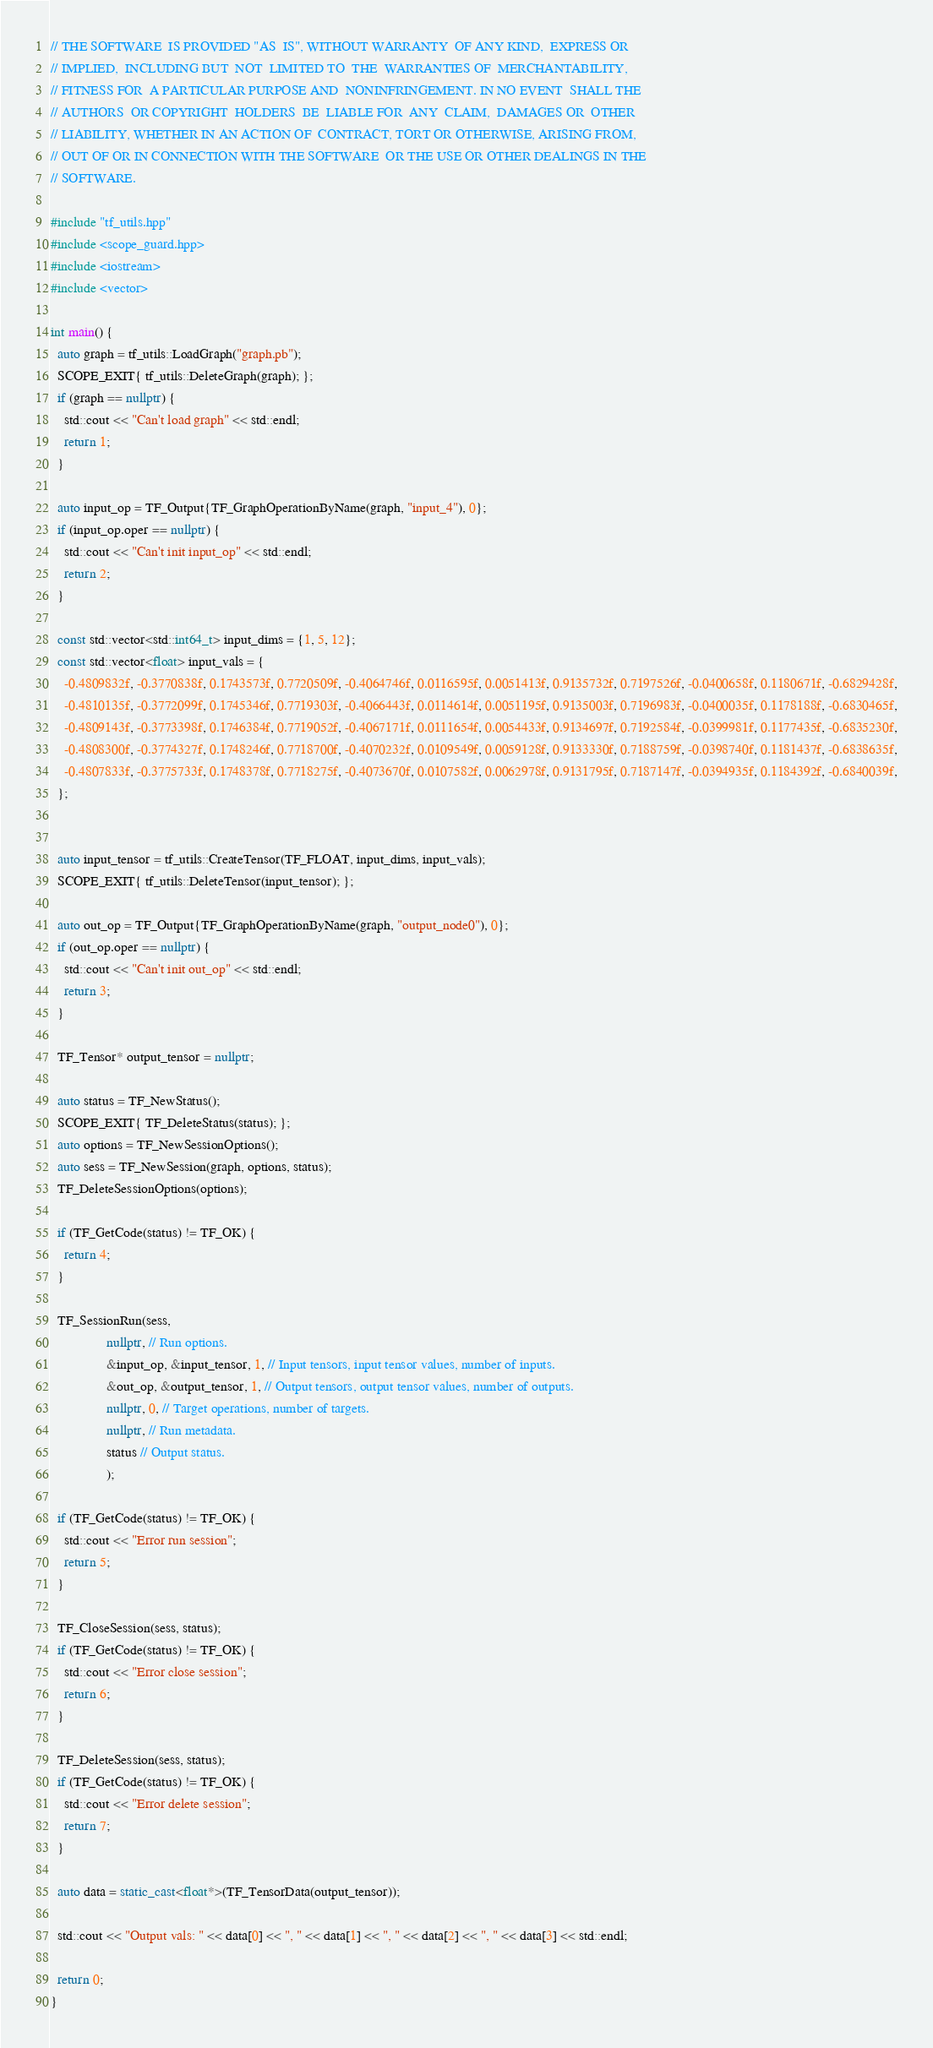<code> <loc_0><loc_0><loc_500><loc_500><_C++_>// THE SOFTWARE  IS PROVIDED "AS  IS", WITHOUT WARRANTY  OF ANY KIND,  EXPRESS OR
// IMPLIED,  INCLUDING BUT  NOT  LIMITED TO  THE  WARRANTIES OF  MERCHANTABILITY,
// FITNESS FOR  A PARTICULAR PURPOSE AND  NONINFRINGEMENT. IN NO EVENT  SHALL THE
// AUTHORS  OR COPYRIGHT  HOLDERS  BE  LIABLE FOR  ANY  CLAIM,  DAMAGES OR  OTHER
// LIABILITY, WHETHER IN AN ACTION OF  CONTRACT, TORT OR OTHERWISE, ARISING FROM,
// OUT OF OR IN CONNECTION WITH THE SOFTWARE  OR THE USE OR OTHER DEALINGS IN THE
// SOFTWARE.

#include "tf_utils.hpp"
#include <scope_guard.hpp>
#include <iostream>
#include <vector>

int main() {
  auto graph = tf_utils::LoadGraph("graph.pb");
  SCOPE_EXIT{ tf_utils::DeleteGraph(graph); };
  if (graph == nullptr) {
    std::cout << "Can't load graph" << std::endl;
    return 1;
  }

  auto input_op = TF_Output{TF_GraphOperationByName(graph, "input_4"), 0};
  if (input_op.oper == nullptr) {
    std::cout << "Can't init input_op" << std::endl;
    return 2;
  }

  const std::vector<std::int64_t> input_dims = {1, 5, 12};
  const std::vector<float> input_vals = {
    -0.4809832f, -0.3770838f, 0.1743573f, 0.7720509f, -0.4064746f, 0.0116595f, 0.0051413f, 0.9135732f, 0.7197526f, -0.0400658f, 0.1180671f, -0.6829428f,
    -0.4810135f, -0.3772099f, 0.1745346f, 0.7719303f, -0.4066443f, 0.0114614f, 0.0051195f, 0.9135003f, 0.7196983f, -0.0400035f, 0.1178188f, -0.6830465f,
    -0.4809143f, -0.3773398f, 0.1746384f, 0.7719052f, -0.4067171f, 0.0111654f, 0.0054433f, 0.9134697f, 0.7192584f, -0.0399981f, 0.1177435f, -0.6835230f,
    -0.4808300f, -0.3774327f, 0.1748246f, 0.7718700f, -0.4070232f, 0.0109549f, 0.0059128f, 0.9133330f, 0.7188759f, -0.0398740f, 0.1181437f, -0.6838635f,
    -0.4807833f, -0.3775733f, 0.1748378f, 0.7718275f, -0.4073670f, 0.0107582f, 0.0062978f, 0.9131795f, 0.7187147f, -0.0394935f, 0.1184392f, -0.6840039f,
  };


  auto input_tensor = tf_utils::CreateTensor(TF_FLOAT, input_dims, input_vals);
  SCOPE_EXIT{ tf_utils::DeleteTensor(input_tensor); };

  auto out_op = TF_Output{TF_GraphOperationByName(graph, "output_node0"), 0};
  if (out_op.oper == nullptr) {
    std::cout << "Can't init out_op" << std::endl;
    return 3;
  }

  TF_Tensor* output_tensor = nullptr;

  auto status = TF_NewStatus();
  SCOPE_EXIT{ TF_DeleteStatus(status); };
  auto options = TF_NewSessionOptions();
  auto sess = TF_NewSession(graph, options, status);
  TF_DeleteSessionOptions(options);

  if (TF_GetCode(status) != TF_OK) {
    return 4;
  }

  TF_SessionRun(sess,
                nullptr, // Run options.
                &input_op, &input_tensor, 1, // Input tensors, input tensor values, number of inputs.
                &out_op, &output_tensor, 1, // Output tensors, output tensor values, number of outputs.
                nullptr, 0, // Target operations, number of targets.
                nullptr, // Run metadata.
                status // Output status.
                );

  if (TF_GetCode(status) != TF_OK) {
    std::cout << "Error run session";
    return 5;
  }

  TF_CloseSession(sess, status);
  if (TF_GetCode(status) != TF_OK) {
    std::cout << "Error close session";
    return 6;
  }

  TF_DeleteSession(sess, status);
  if (TF_GetCode(status) != TF_OK) {
    std::cout << "Error delete session";
    return 7;
  }

  auto data = static_cast<float*>(TF_TensorData(output_tensor));

  std::cout << "Output vals: " << data[0] << ", " << data[1] << ", " << data[2] << ", " << data[3] << std::endl;

  return 0;
}
</code> 